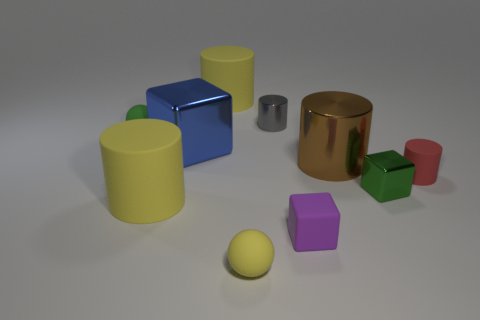Subtract 2 cylinders. How many cylinders are left? 3 Subtract all gray cylinders. How many cylinders are left? 4 Subtract all large shiny cylinders. How many cylinders are left? 4 Subtract all gray cylinders. Subtract all purple spheres. How many cylinders are left? 4 Subtract all spheres. How many objects are left? 8 Add 6 small gray metallic cylinders. How many small gray metallic cylinders are left? 7 Add 3 large yellow rubber cylinders. How many large yellow rubber cylinders exist? 5 Subtract 1 brown cylinders. How many objects are left? 9 Subtract all green blocks. Subtract all big brown shiny cylinders. How many objects are left? 8 